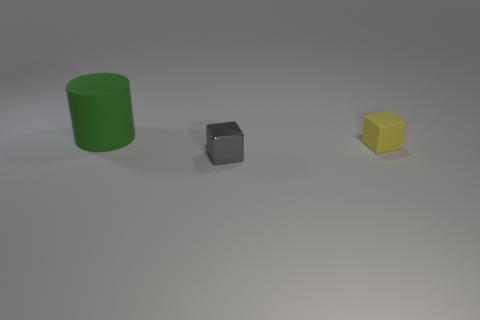What kind of mood or atmosphere does the image evoke? The image has a minimalist and clean aesthetic, evoking a sense of calmness and simplicity. The muted colors and the soft lighting contribute to a serene and uncluttered atmosphere. 